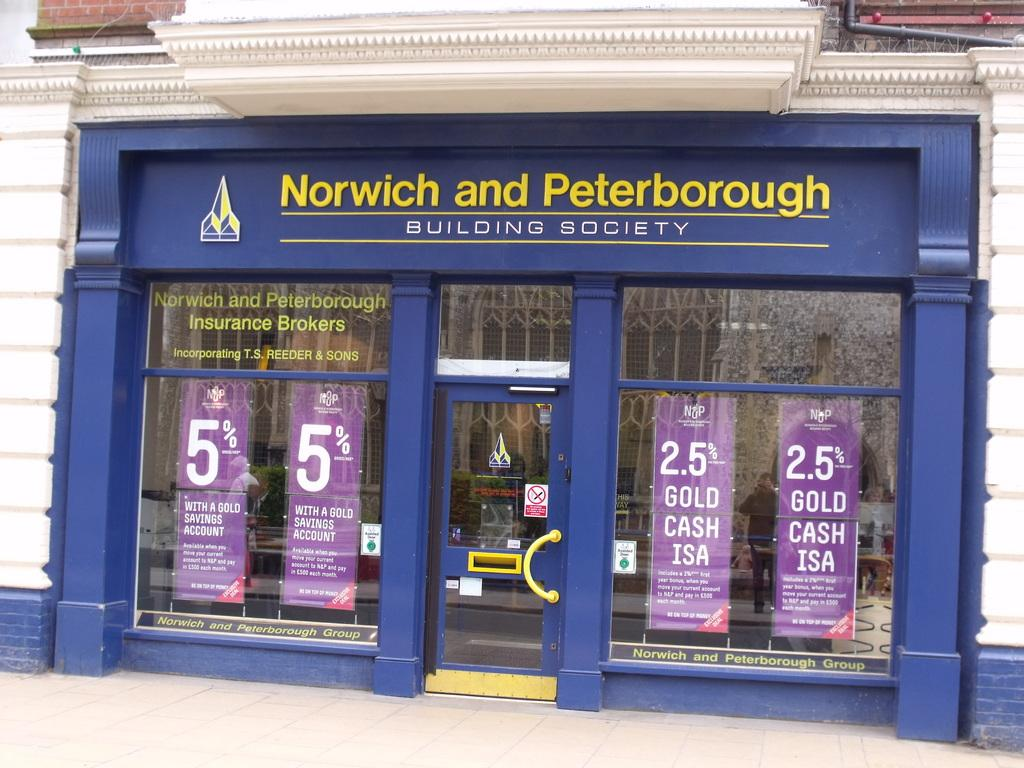What is the main structure visible in the image? There is a building in the image. What decorations or features can be seen on the building? There are posters on the building. Where is the cub located in the image? There is no cub present in the image. What type of medical assistance is being provided in the image? There is no doctor or medical assistance present in the image. 